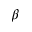<formula> <loc_0><loc_0><loc_500><loc_500>\beta</formula> 